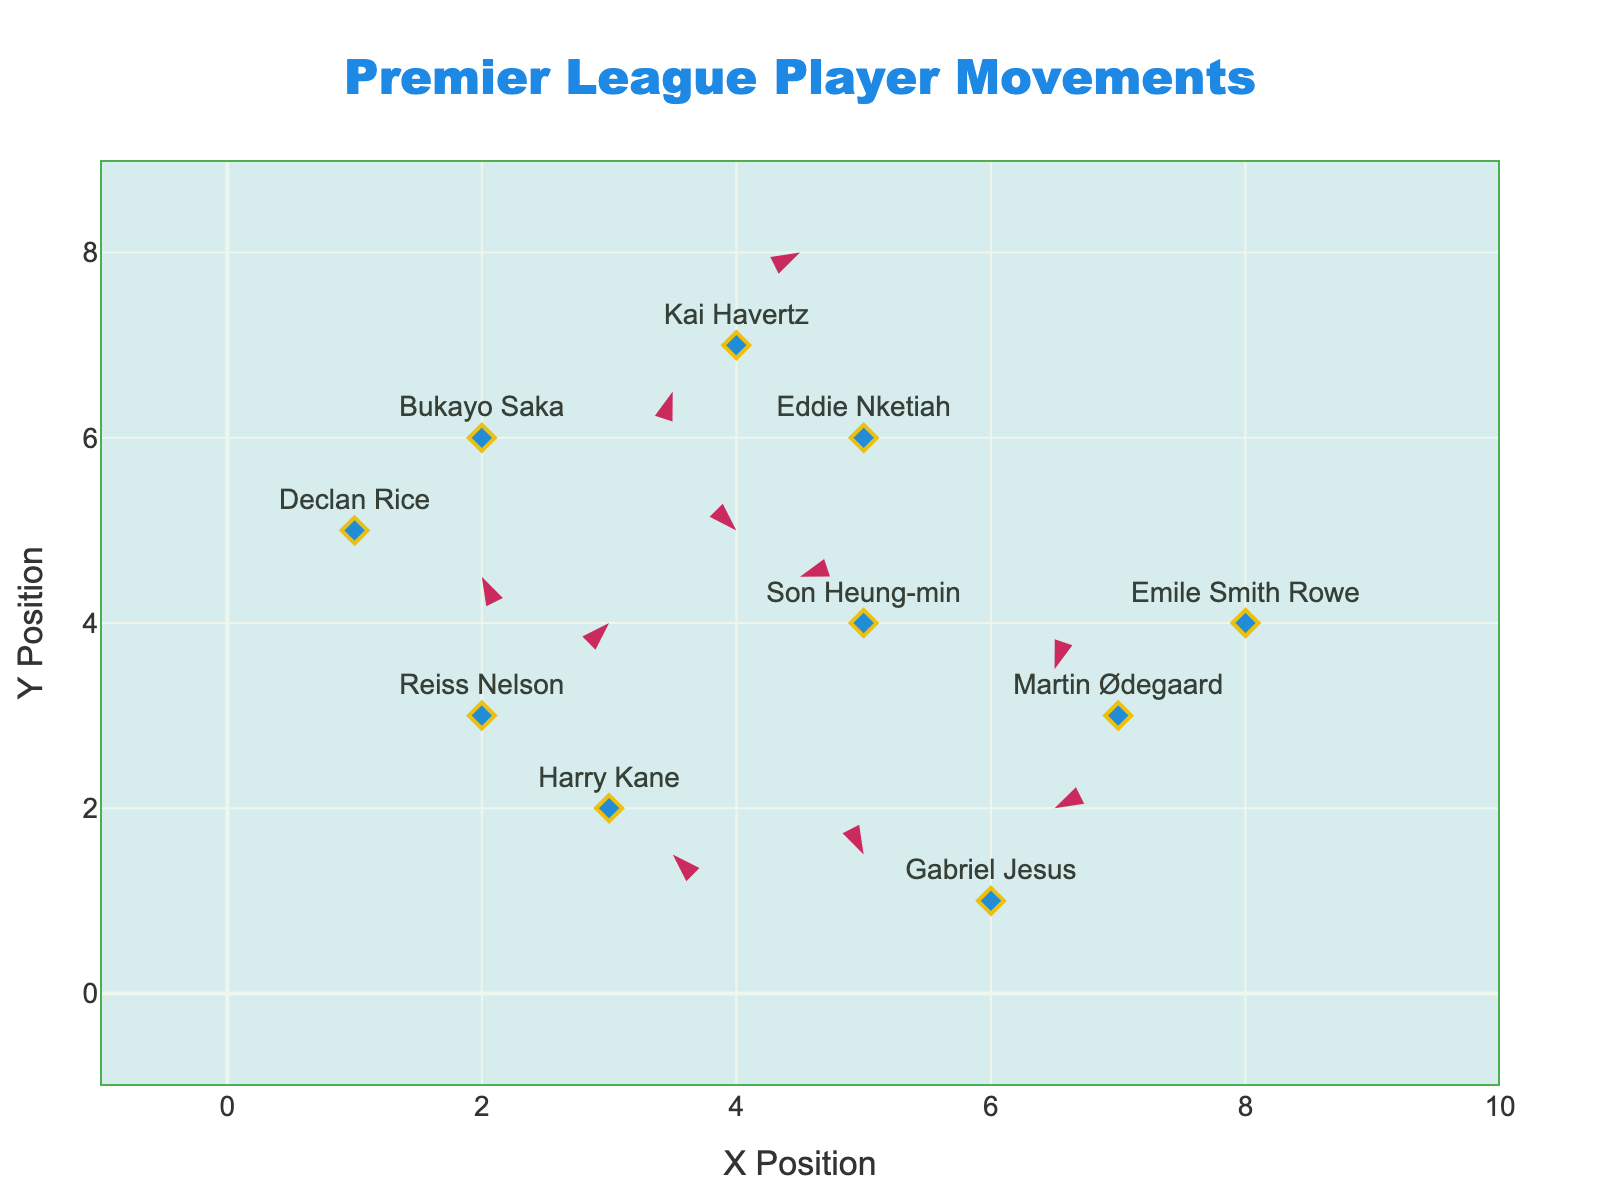What's the title of the plot? The title is at the top and reads "Premier League Player Movements" with a specific font and color.
Answer: Premier League Player Movements How many players are shown in this plot? Each player's name is displayed along with a marker indicating their position on the plot. Counting all the names will give us the total number of players.
Answer: 10 What are the axis labels on the plot? The x and y axes have titles in the figure. Looking at the axes will reveal these labels.
Answer: X Position, Y Position Which player has the largest horizontal movement? To determine this, check both the u and x values. The player with the highest magnitude of u (positive or negative) indicates the largest horizontal movement. Bukayo Saka has u = 3, the largest value.
Answer: Bukayo Saka Which player moved vertically downward the most? Vertical downward movement is indicated by negative v values. Checking all the v values, Emile Smith Rowe has v = -1, but Eddie Nketiah has v = -3, which is the most significant downward movement.
Answer: Eddie Nketiah What's the sum of all horizontal movements (u values)? Summing all the u values: 1 + (-2) + 3 + (-1) + 2 + (-2) + 1 + (-3) + 2 + (-1) = 0.
Answer: 0 Which player is nearest to the origin (0,0)? Calculate the distance from the origin for each player using the formula √(x² + y²). The smallest distance indicates the nearest player. Declan Rice is at (1,5), distance √(1² + 5²) = √26 ≈ 5.1 which is the smallest.
Answer: Declan Rice Which player has the greatest total movement (Euclidean distance)? Calculate the Euclidean distance for movement using the formula √(u² + v²) for each player. Bukayo Saka has the largest distance with √(3² + 1²) = √10 ≈ 3.16.
Answer: Bukayo Saka Who has the shortest arrow associated with their movement? Shortest movement can be found by the smallest Euclidean distance √(u² + v²). Martin Ødegaard has a movement vector (-1, -2) with the shortest distance of √(1² + 2²) = √5 ≈ 2.24.
Answer: Martin Ødegaard Who is the only player moving straight horizontally without any vertical movement? A horizontal movement with no vertical component would mean v = 0. However, all players in this plot have non-zero vertical components. Therefore, nobody fits this criterion.
Answer: None 